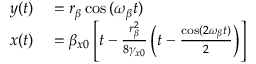<formula> <loc_0><loc_0><loc_500><loc_500>\begin{array} { r l } { y ( t ) } & = r _ { \beta } \cos { ( \omega _ { \beta } t ) } } \\ { x ( t ) } & = \beta _ { x 0 } \left [ t - \frac { r _ { \beta } ^ { 2 } } { 8 \gamma _ { x 0 } } \left ( t - \frac { \cos ( 2 \omega _ { \beta } t ) } { 2 } \right ) \right ] } \end{array}</formula> 